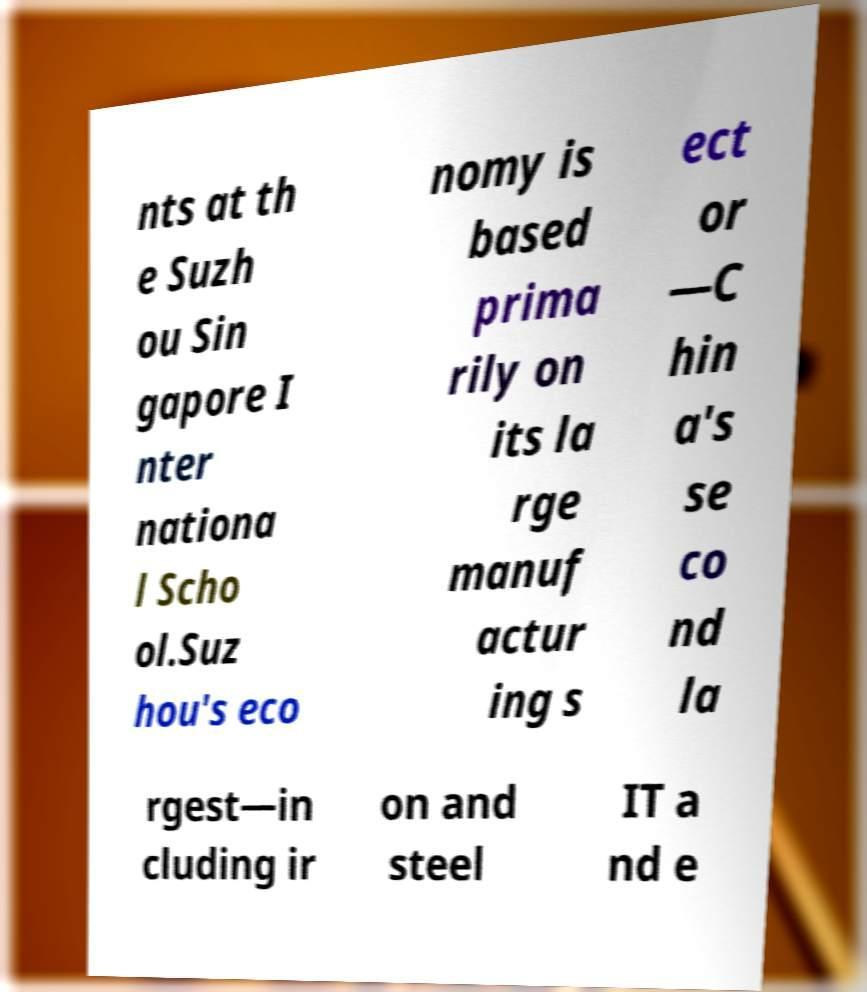Please identify and transcribe the text found in this image. nts at th e Suzh ou Sin gapore I nter nationa l Scho ol.Suz hou's eco nomy is based prima rily on its la rge manuf actur ing s ect or —C hin a's se co nd la rgest—in cluding ir on and steel IT a nd e 